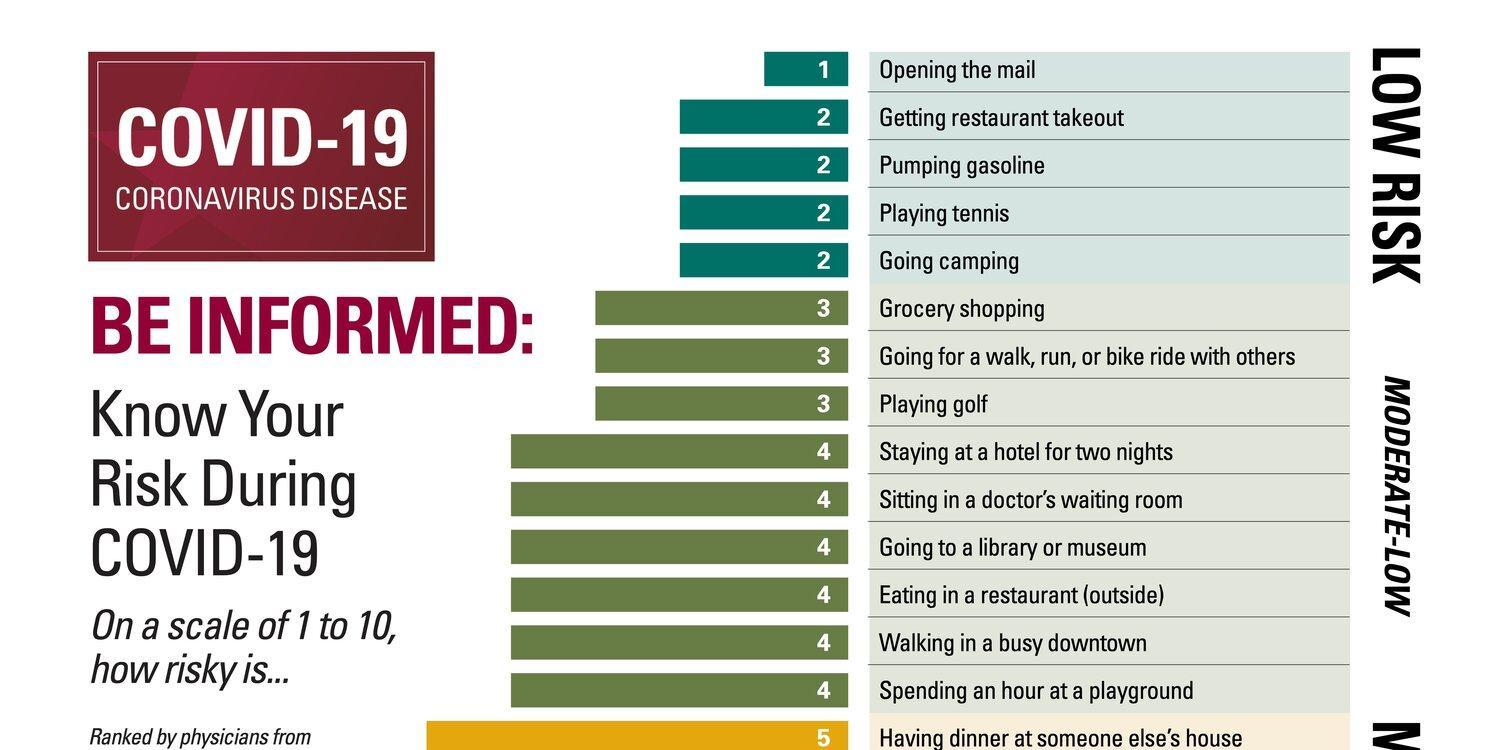How many actions are at low risk?
Answer the question with a short phrase. 5 How many actions with risk factor 2? 4 How many actions with risk factor 4? 6 How many actions with risk factor 5? 1 How many actions are at moderate-low risk? 9 